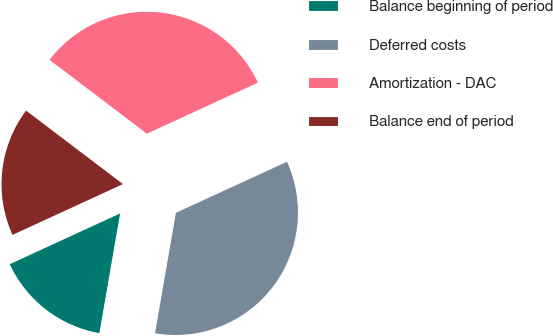Convert chart to OTSL. <chart><loc_0><loc_0><loc_500><loc_500><pie_chart><fcel>Balance beginning of period<fcel>Deferred costs<fcel>Amortization - DAC<fcel>Balance end of period<nl><fcel>15.41%<fcel>34.59%<fcel>32.81%<fcel>17.19%<nl></chart> 